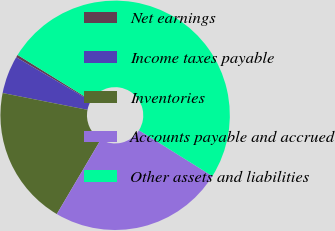Convert chart. <chart><loc_0><loc_0><loc_500><loc_500><pie_chart><fcel>Net earnings<fcel>Income taxes payable<fcel>Inventories<fcel>Accounts payable and accrued<fcel>Other assets and liabilities<nl><fcel>0.37%<fcel>5.34%<fcel>19.62%<fcel>24.59%<fcel>50.07%<nl></chart> 